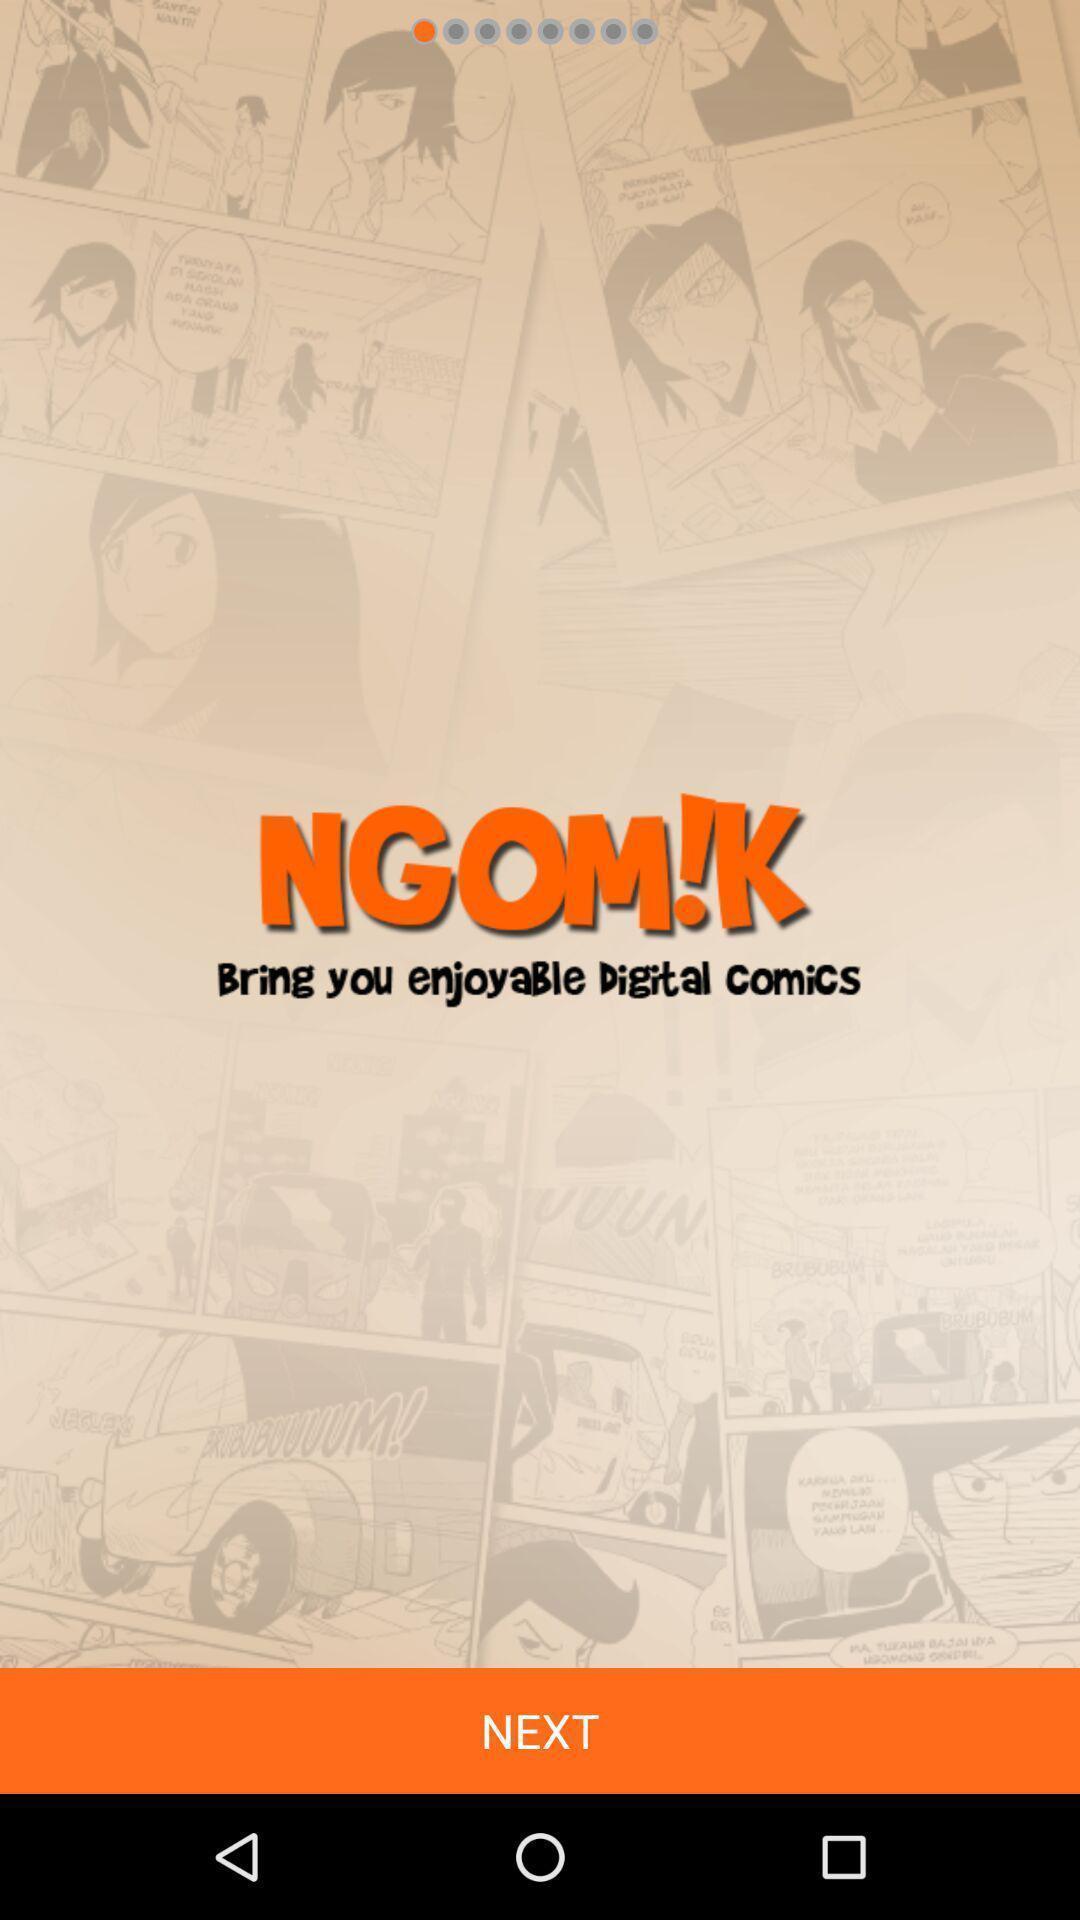Summarize the information in this screenshot. Welcome page. 